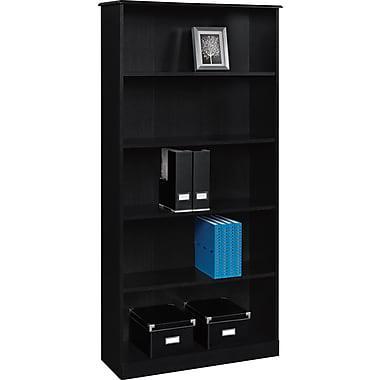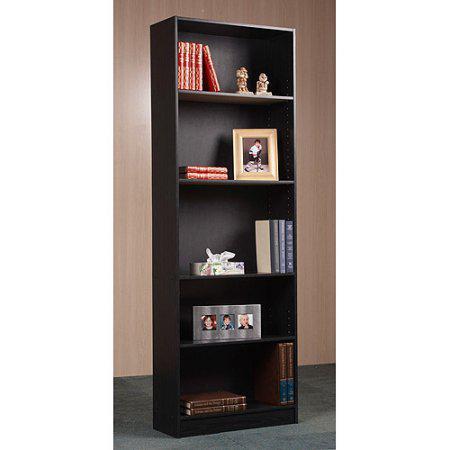The first image is the image on the left, the second image is the image on the right. For the images shown, is this caption "There is a white pail shaped vase on a shelf." true? Answer yes or no. No. 